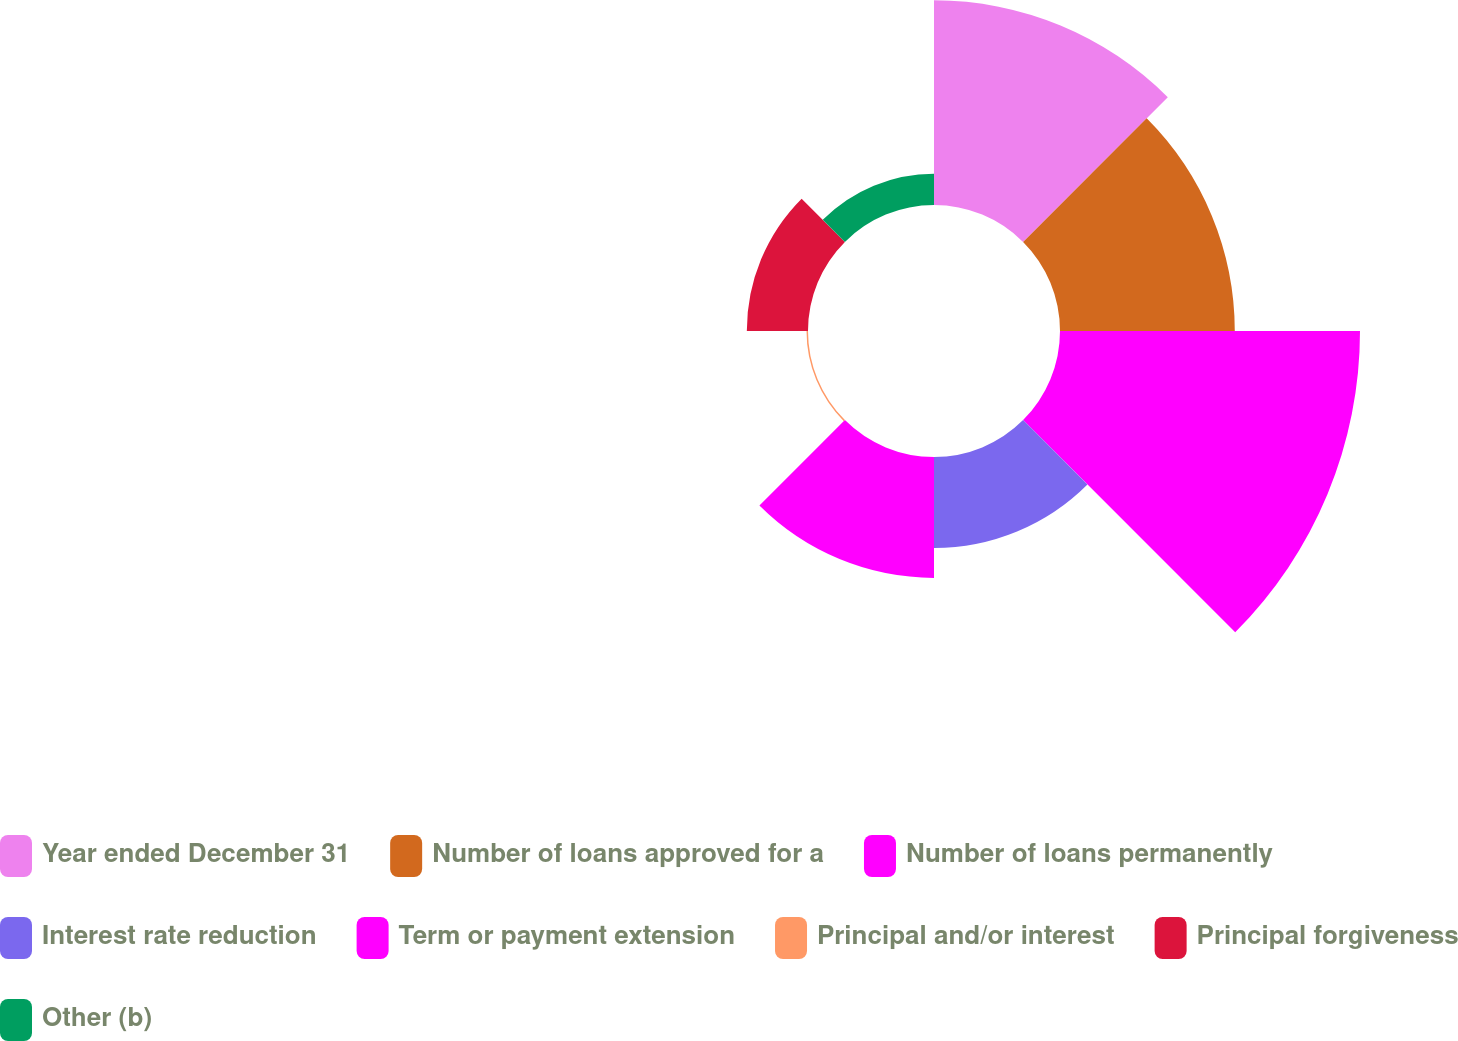Convert chart. <chart><loc_0><loc_0><loc_500><loc_500><pie_chart><fcel>Year ended December 31<fcel>Number of loans approved for a<fcel>Number of loans permanently<fcel>Interest rate reduction<fcel>Term or payment extension<fcel>Principal and/or interest<fcel>Principal forgiveness<fcel>Other (b)<nl><fcel>20.77%<fcel>17.74%<fcel>30.45%<fcel>9.24%<fcel>12.27%<fcel>0.15%<fcel>6.21%<fcel>3.18%<nl></chart> 